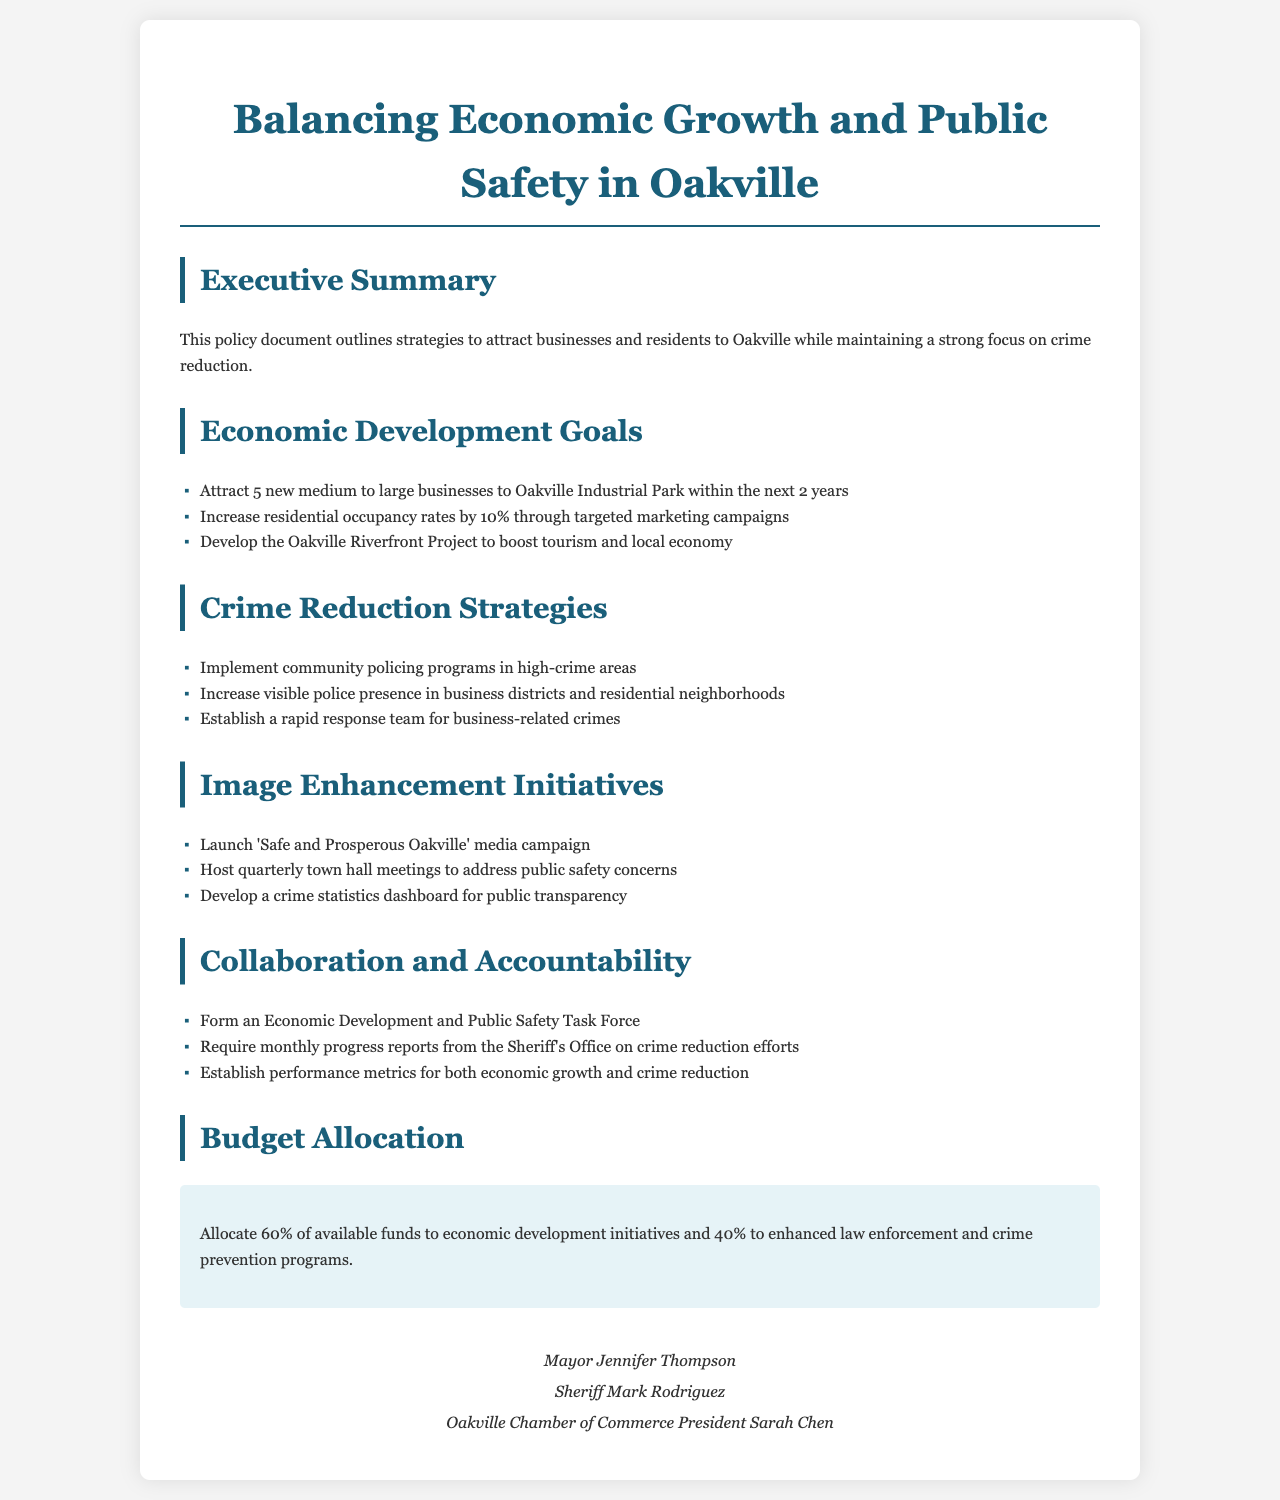What are the economic development goals? The economic development goals are listed in the document, including attracting new businesses and increasing residential occupancy rates.
Answer: Attract 5 new medium to large businesses to Oakville Industrial Park within the next 2 years, Increase residential occupancy rates by 10% What percentage of the budget is allocated to economic development initiatives? The document specifies the budget allocation for economic development initiatives.
Answer: 60% What is one strategy for crime reduction? The crime reduction strategies are outlined in the document, including various approaches aimed at achieving safety in Oakville.
Answer: Implement community policing programs in high-crime areas Who is the Sheriff mentioned in the document? The document lists individuals who signed the policy, including the Sheriff.
Answer: Mark Rodriguez What is the title of the document? The title is explicitly stated at the beginning of the document.
Answer: Balancing Economic Growth and Public Safety in Oakville What is one of the image enhancement initiatives? The document includes a section specifically detailing initiatives aimed at enhancing the town's image.
Answer: Launch 'Safe and Prosperous Oakville' media campaign How often are progress reports required from the Sheriff's Office? The collaboration and accountability section highlights expectations for reporting.
Answer: Monthly What is the goal for increasing residential occupancy rates? The document outlines specific targets within its economic development goals.
Answer: Increase residential occupancy rates by 10% 